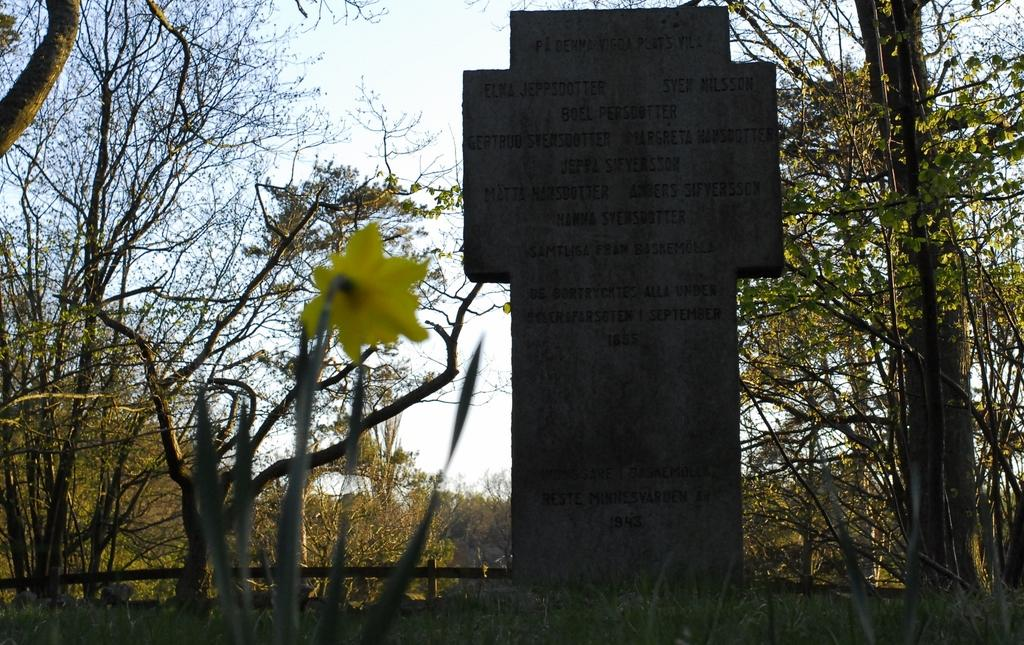What is the main object in the image? There is a headstone in the image. What can be found on the headstone? There is writing on the headstone. What can be seen in the background of the image? There is a fence and trees in the background of the image. What metal object is being observed in the image? There is no metal object being observed in the image; the headstone is made of stone, and the fence in the background is likely made of metal, but it is not the main focus of the image. 